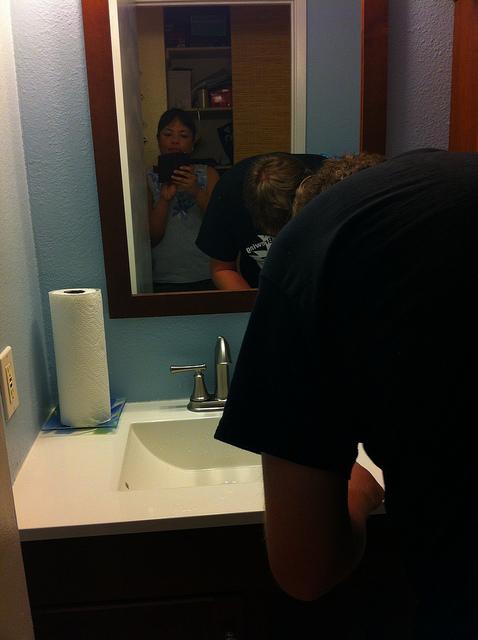What color is the outer edge of the mirror?
Short answer required. Brown. Is this a bathroom?
Concise answer only. Yes. What can you see in the mirror besides the man's reflection?
Quick response, please. Woman. What room is this?
Be succinct. Bathroom. Is the door behind this person open?
Write a very short answer. Yes. What time of year might it be?
Keep it brief. Summer. What is the child making?
Quick response, please. Nothing. How many people are in the mirror?
Give a very brief answer. 2. What color is the walls in the room?
Be succinct. Blue. What is the man looking at?
Quick response, please. Sink. 